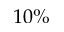<formula> <loc_0><loc_0><loc_500><loc_500>1 0 \%</formula> 